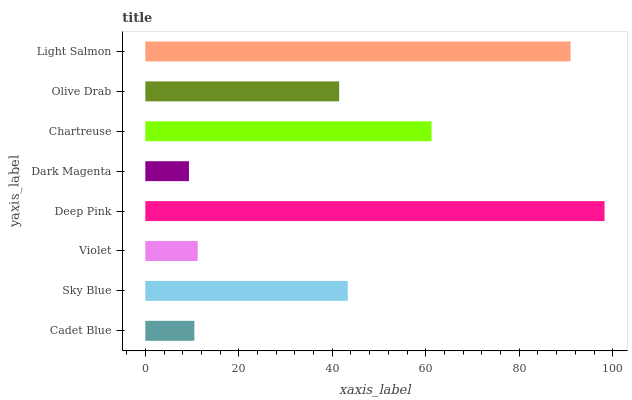Is Dark Magenta the minimum?
Answer yes or no. Yes. Is Deep Pink the maximum?
Answer yes or no. Yes. Is Sky Blue the minimum?
Answer yes or no. No. Is Sky Blue the maximum?
Answer yes or no. No. Is Sky Blue greater than Cadet Blue?
Answer yes or no. Yes. Is Cadet Blue less than Sky Blue?
Answer yes or no. Yes. Is Cadet Blue greater than Sky Blue?
Answer yes or no. No. Is Sky Blue less than Cadet Blue?
Answer yes or no. No. Is Sky Blue the high median?
Answer yes or no. Yes. Is Olive Drab the low median?
Answer yes or no. Yes. Is Chartreuse the high median?
Answer yes or no. No. Is Chartreuse the low median?
Answer yes or no. No. 